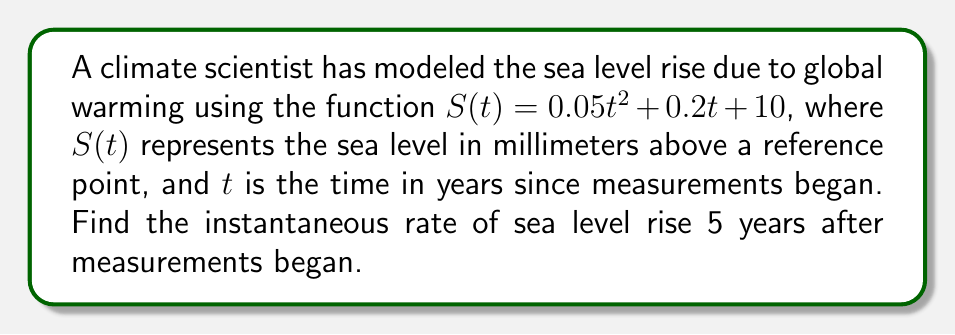Can you answer this question? To find the instantaneous rate of sea level rise, we need to calculate the derivative of the function $S(t)$ and evaluate it at $t = 5$. Let's follow these steps:

1) The given function is $S(t) = 0.05t^2 + 0.2t + 10$

2) To find the derivative, we apply the power rule and constant rule:
   $$\frac{dS}{dt} = 0.05 \cdot 2t^{2-1} + 0.2 + 0$$

3) Simplify:
   $$\frac{dS}{dt} = 0.1t + 0.2$$

4) This derivative represents the instantaneous rate of change of sea level with respect to time.

5) To find the rate at $t = 5$, we substitute $t = 5$ into our derivative:
   $$\frac{dS}{dt}\bigg|_{t=5} = 0.1(5) + 0.2 = 0.5 + 0.2 = 0.7$$

6) Therefore, the instantaneous rate of sea level rise 5 years after measurements began is 0.7 mm/year.
Answer: 0.7 mm/year 